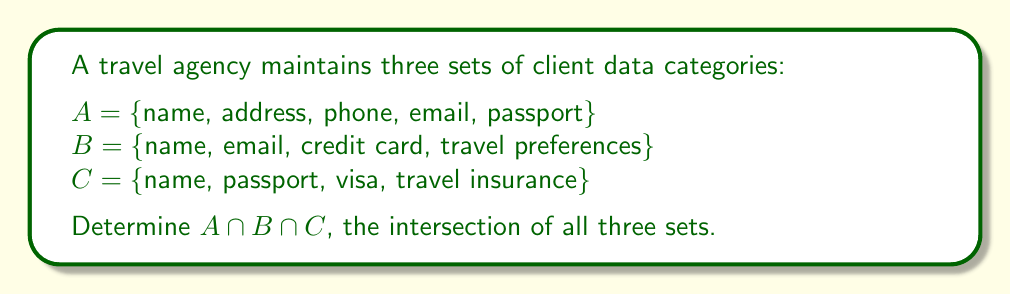Can you answer this question? To find the intersection of all three sets, we need to identify the elements that are common to all sets A, B, and C.

Let's analyze each set:

1. Set A: {name, address, phone, email, passport}
2. Set B: {name, email, credit card, travel preferences}
3. Set C: {name, passport, visa, travel insurance}

We can see that:
- "name" appears in all three sets
- "email" appears in A and B, but not in C
- "passport" appears in A and C, but not in B

The intersection of all three sets, denoted as $A \cap B \cap C$, will contain only the elements that are present in all three sets simultaneously.

Therefore, the only element that satisfies this condition is "name".

We can represent this mathematically as:

$$A \cap B \cap C = \{name\}$$

This result indicates that the only piece of client information consistently present across all three data categories is the client's name.
Answer: $A \cap B \cap C = \{name\}$ 